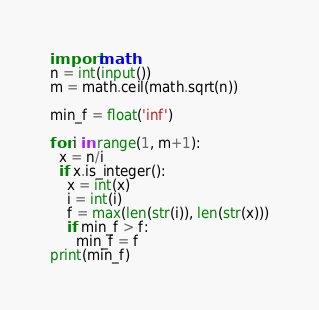<code> <loc_0><loc_0><loc_500><loc_500><_Python_>import math
n = int(input())
m = math.ceil(math.sqrt(n))

min_f = float('inf')

for i in range(1, m+1):
  x = n/i
  if x.is_integer():
    x = int(x)
    i = int(i)
    f = max(len(str(i)), len(str(x)))
    if min_f > f:
      min_f = f
print(min_f)
</code> 